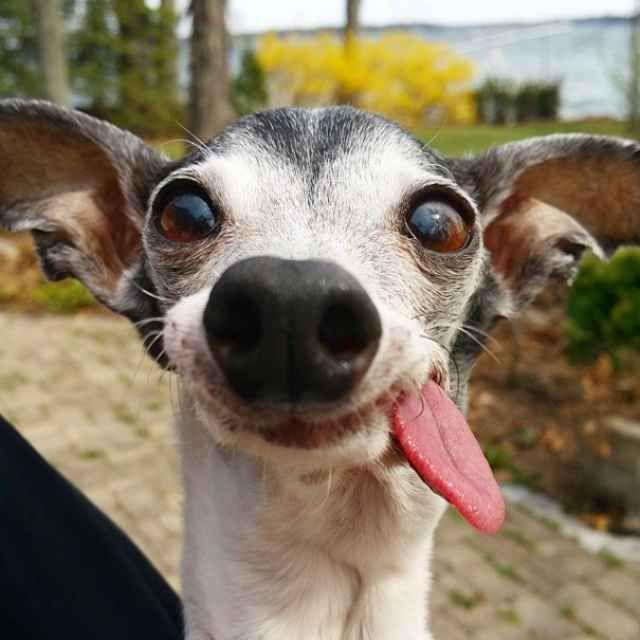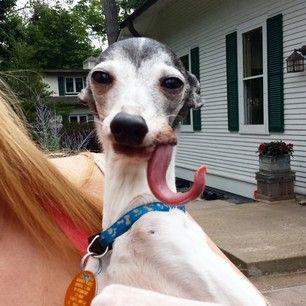The first image is the image on the left, the second image is the image on the right. Evaluate the accuracy of this statement regarding the images: "At least one of the images includes a dog interacting with an ice cream cone.". Is it true? Answer yes or no. No. The first image is the image on the left, the second image is the image on the right. Examine the images to the left and right. Is the description "There is two dogs in the right image." accurate? Answer yes or no. No. 